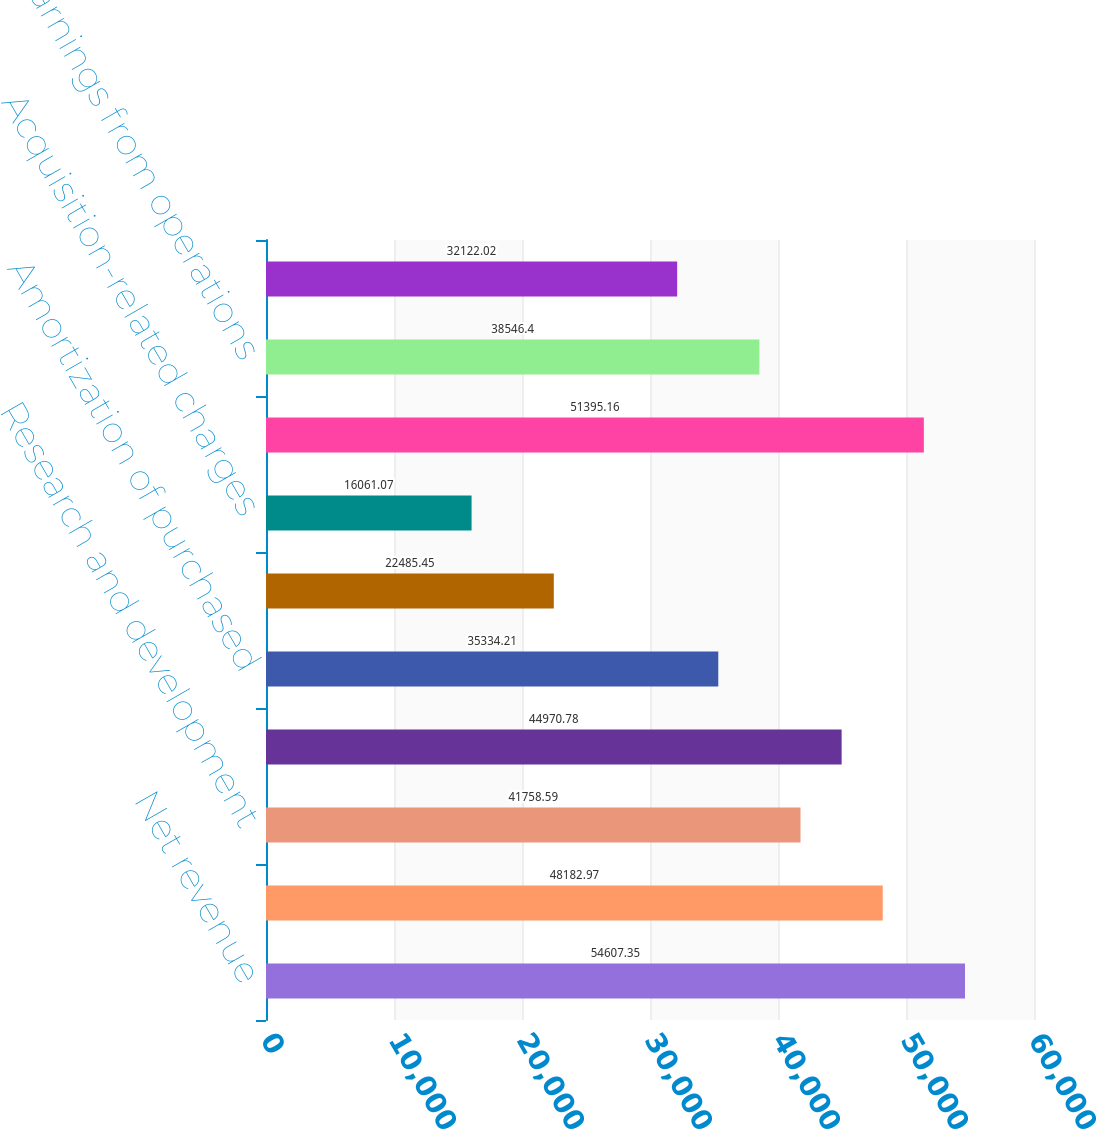Convert chart. <chart><loc_0><loc_0><loc_500><loc_500><bar_chart><fcel>Net revenue<fcel>Cost of sales (1)(3)<fcel>Research and development<fcel>Selling general and<fcel>Amortization of purchased<fcel>Restructuring charges<fcel>Acquisition-related charges<fcel>Total costs and expenses<fcel>Earnings from operations<fcel>Interest and other net<nl><fcel>54607.3<fcel>48183<fcel>41758.6<fcel>44970.8<fcel>35334.2<fcel>22485.5<fcel>16061.1<fcel>51395.2<fcel>38546.4<fcel>32122<nl></chart> 